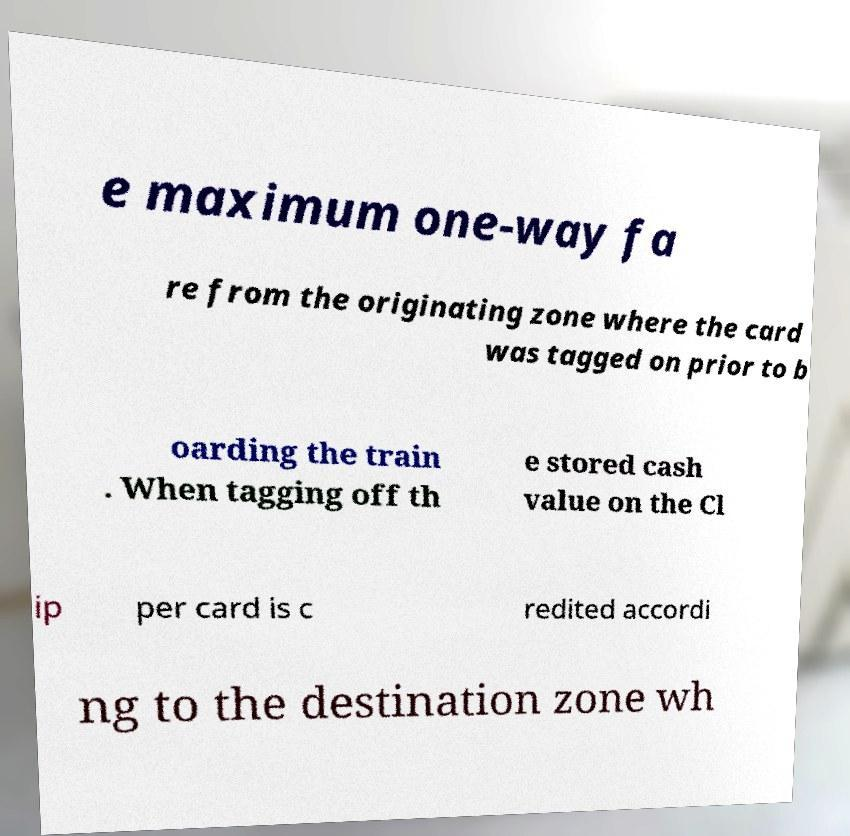Could you extract and type out the text from this image? e maximum one-way fa re from the originating zone where the card was tagged on prior to b oarding the train . When tagging off th e stored cash value on the Cl ip per card is c redited accordi ng to the destination zone wh 